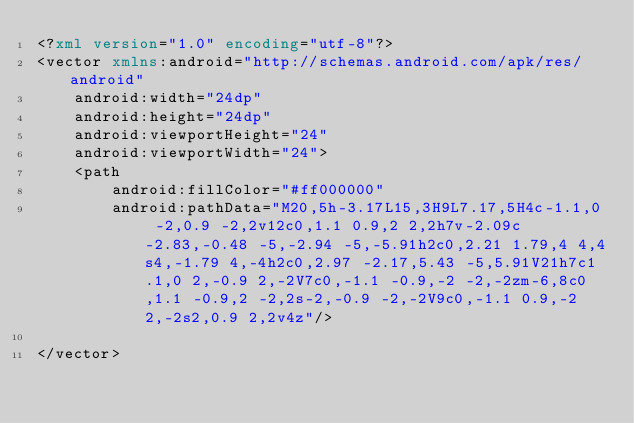Convert code to text. <code><loc_0><loc_0><loc_500><loc_500><_XML_><?xml version="1.0" encoding="utf-8"?>
<vector xmlns:android="http://schemas.android.com/apk/res/android"
    android:width="24dp"
    android:height="24dp"
    android:viewportHeight="24"
    android:viewportWidth="24">
    <path
        android:fillColor="#ff000000"
        android:pathData="M20,5h-3.17L15,3H9L7.17,5H4c-1.1,0 -2,0.9 -2,2v12c0,1.1 0.9,2 2,2h7v-2.09c-2.83,-0.48 -5,-2.94 -5,-5.91h2c0,2.21 1.79,4 4,4s4,-1.79 4,-4h2c0,2.97 -2.17,5.43 -5,5.91V21h7c1.1,0 2,-0.9 2,-2V7c0,-1.1 -0.9,-2 -2,-2zm-6,8c0,1.1 -0.9,2 -2,2s-2,-0.9 -2,-2V9c0,-1.1 0.9,-2 2,-2s2,0.9 2,2v4z"/>

</vector></code> 